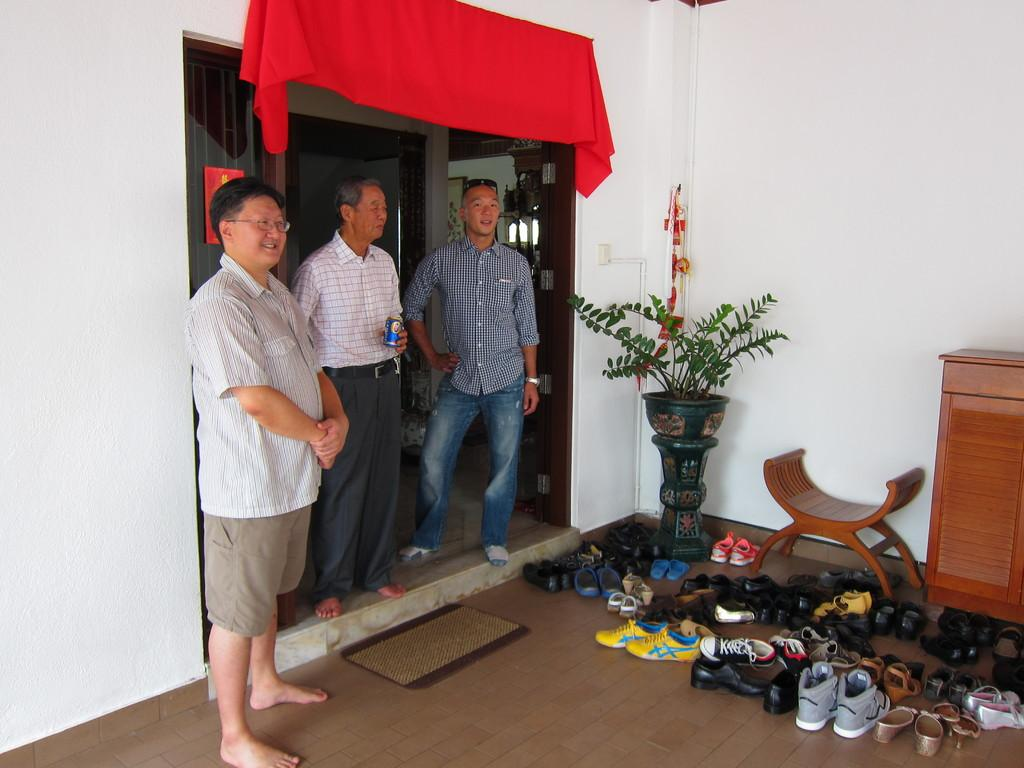How many men are present in the image? There are three men standing on the left side of the image. What furniture is visible in the image? There is a chair and a table in the image. Are there any plants in the image? Yes, there is a house plant in the image. How many pairs of shoes can be seen in the image? There are at least two pairs of shoes in the image. What type of office equipment can be seen in the image? There is no office equipment present in the image. What discovery was made by the men in the image? The image does not depict a discovery or any specific action by the men. 